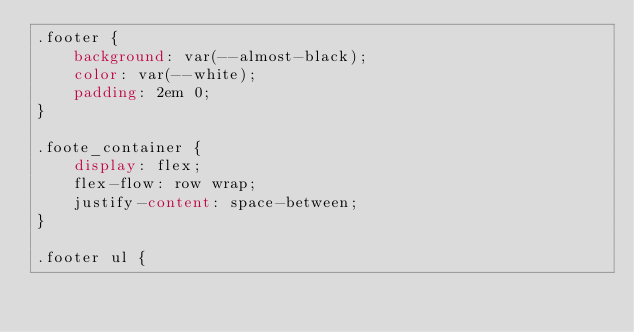<code> <loc_0><loc_0><loc_500><loc_500><_CSS_>.footer {
    background: var(--almost-black);
    color: var(--white);
    padding: 2em 0;
}

.foote_container {
    display: flex;
    flex-flow: row wrap;
    justify-content: space-between;
}

.footer ul {</code> 